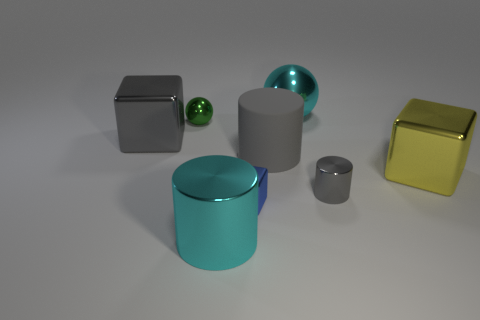What is the shape of the thing that is the same color as the big metal ball?
Make the answer very short. Cylinder. There is a small gray metallic thing; what shape is it?
Your answer should be compact. Cylinder. How many other tiny things have the same shape as the gray matte object?
Give a very brief answer. 1. How many cubes are both in front of the matte cylinder and behind the small metal block?
Make the answer very short. 1. The small shiny ball is what color?
Your answer should be very brief. Green. Are there any small green spheres made of the same material as the small block?
Give a very brief answer. Yes. Are there any metallic things in front of the sphere on the right side of the large cyan object in front of the yellow cube?
Your answer should be compact. Yes. Are there any large metal things on the left side of the tiny green metal sphere?
Offer a very short reply. Yes. Are there any big shiny things that have the same color as the tiny block?
Your answer should be compact. No. How many large objects are either yellow shiny blocks or red things?
Your response must be concise. 1. 